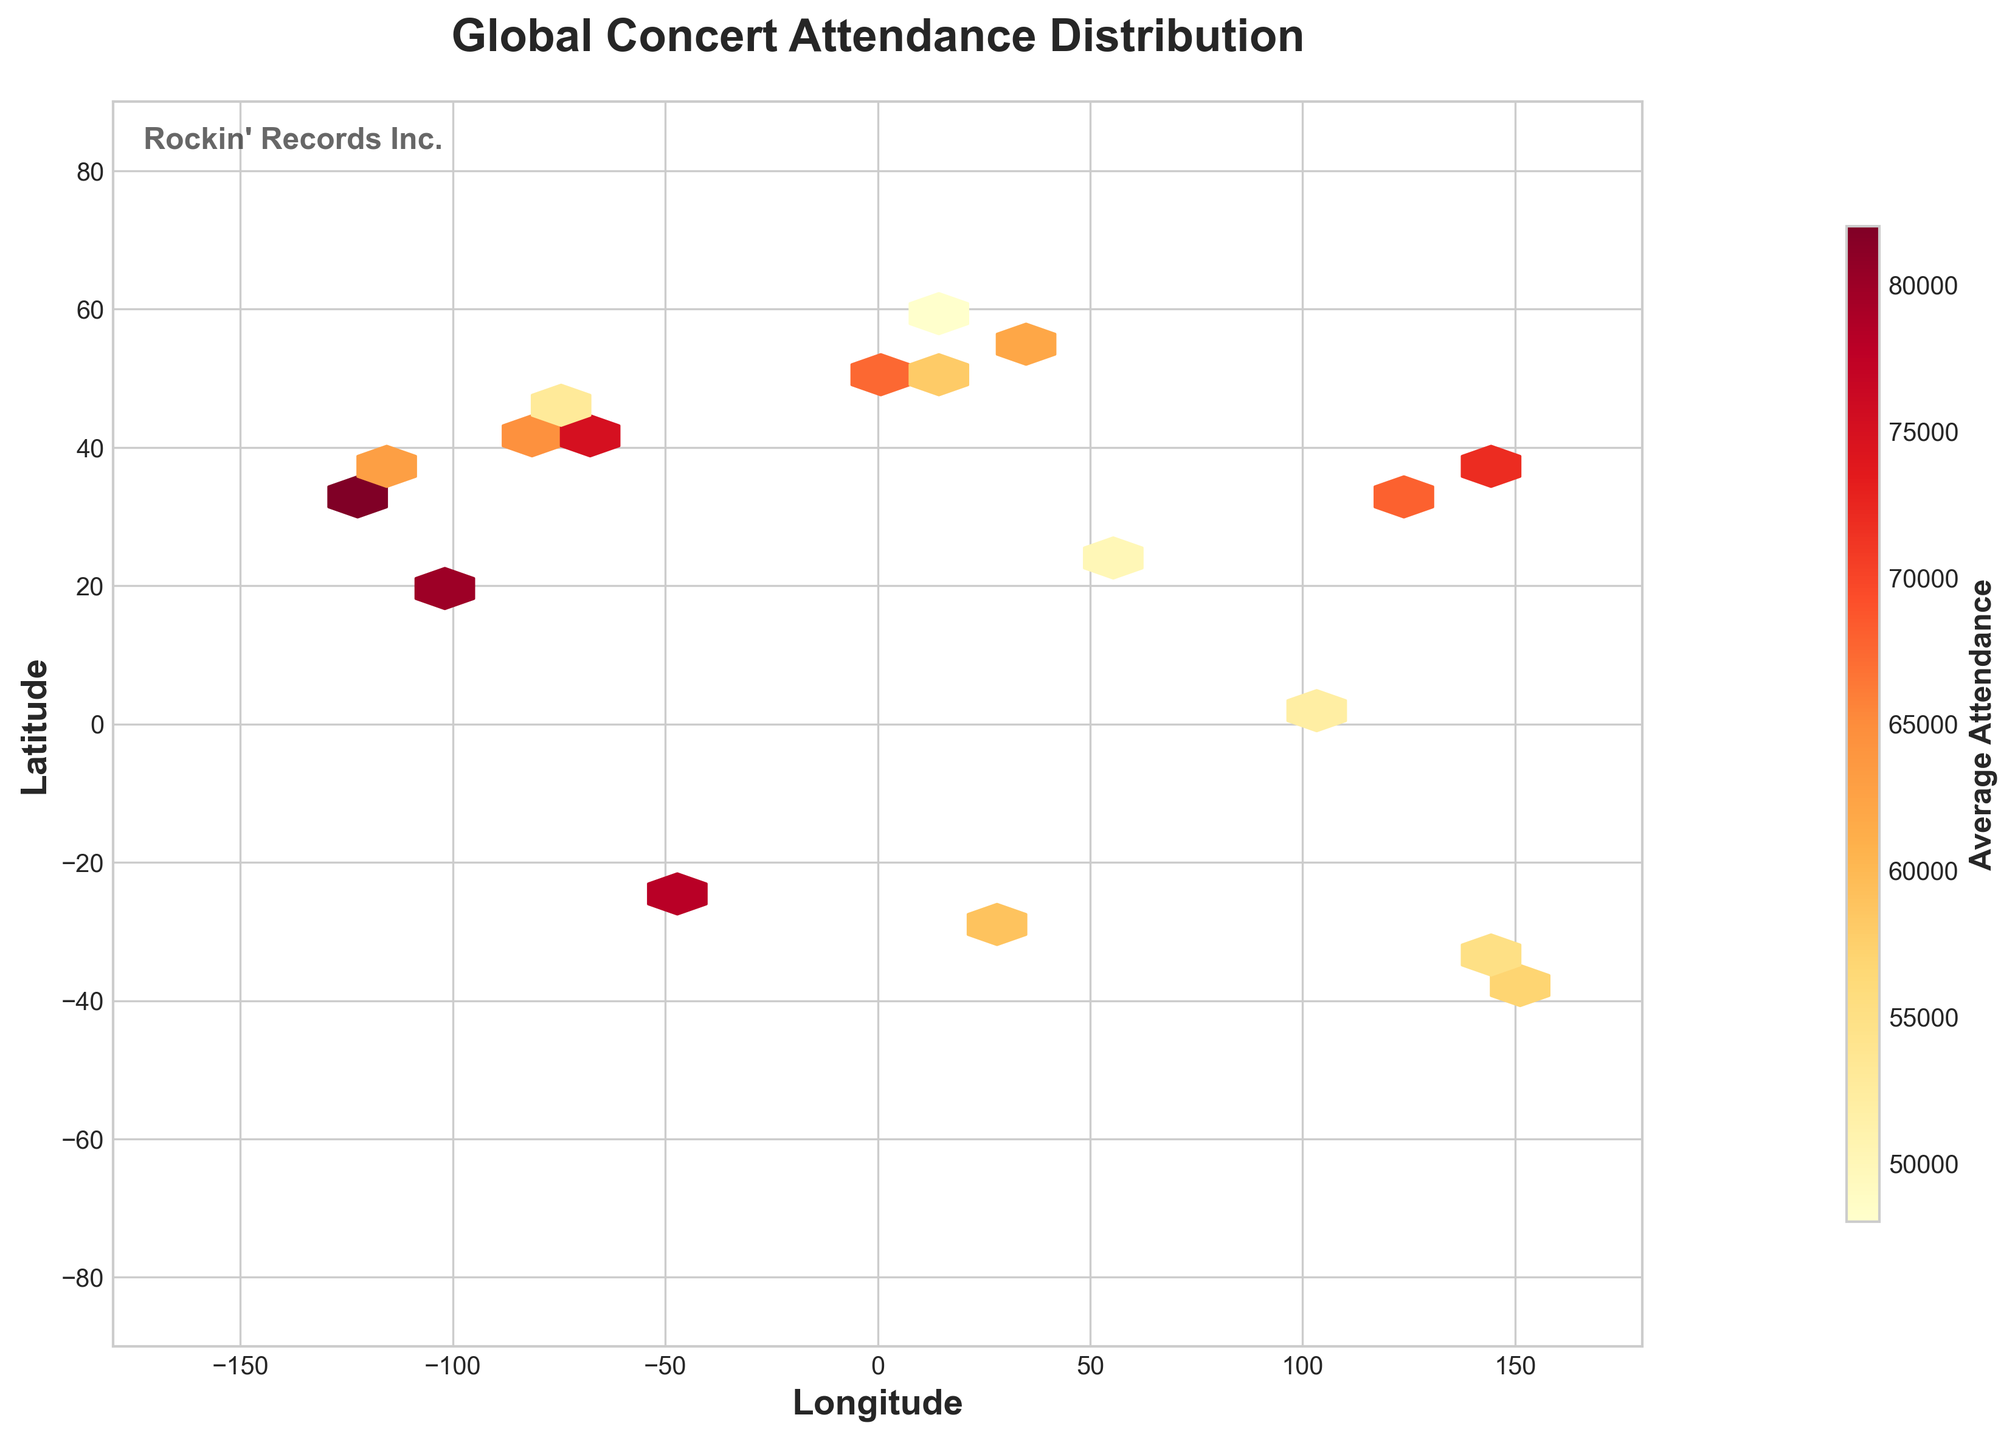what is the title of the figure? The figure's title is usually prominently displayed at the top of the plot in bold and large font. By looking at the top, we can see the text "Global Concert Attendance Distribution".
Answer: Global Concert Attendance Distribution What are the labels of the axes? The labels of the axes are often found next to the respective axes, formatted in a bold font. By inspecting the plot, the x-axis label reads "Longitude" and the y-axis label reads "Latitude".
Answer: Longitude, Latitude What does the colorbar represent? The colorbar typically provides information on what the color intensity stands for in the plot. In this case, it is labeled "Average Attendance", indicating it shows the average attendance at concerts.
Answer: Average Attendance What range of longitudes is covered in the plot? The x-axis, also known as the longitude axis, spans from the minimum to the maximum longitude values seen on it. Observing the range, the plot covers longitudes from -180 to 180 degrees.
Answer: -180 to 180 degrees What does a darker color in the hexbin represent? A darker color in the hexbin plot indicates a higher value based on the color coding established by the colorbar. Here, it signifies a higher average concert attendance.
Answer: Higher average concert attendance Which city has the highest average concert attendance? By looking at the color intensity on the hexbin plot and identifying the specific plot point, the city with the darkest hexbin represents the highest average attendance. From the given data, 34.0522, -118.2437 (Los Angeles) corresponds to the highest attendance with 82,000.
Answer: Los Angeles What city lies at latitude 51.5074 and what is its average concert attendance? Referring to the city coordinates in the data, the one at 51.5074 latitude is London. The plot shows hexbin color intensity, and from the given data, the average concert attendance there is 70,000.
Answer: London, 70,000 Where is the concert attendance relatively low in East Asia based on the plot? By inspecting hexbin colors and referring to East Asia's coordinates, the relatively lighter colors give clues. Based on this, Shanghai (31.2304, 121.4737) shows a relatively lower attendance with 68,000 compared to Tokyo's 72,000.
Answer: Shanghai What is the average attendance for concerts in Europe? Europe includes cities like London, Paris, Berlin, and Stockholm. By averaging the attendance values (70,000 + 65,000 + 58,000 + 48,000) and calculating (70,00+65,000+58,000+48,000) / 4, we get 60,250.
Answer: 60,250 How does attendance in North American cities compare to that in South American cities? First, identify North American cities (New York, Chicago, Ottawa, Toronto) and South American cities (Sao Paulo). Compare their attendance values: North America (75,000 + 68,000 + 53,000 + 61,000) = 257,000; South America (78,000). By comparing the sums or averages, North America has overall higher or comparable attendance on average.
Answer: Higher in North America 